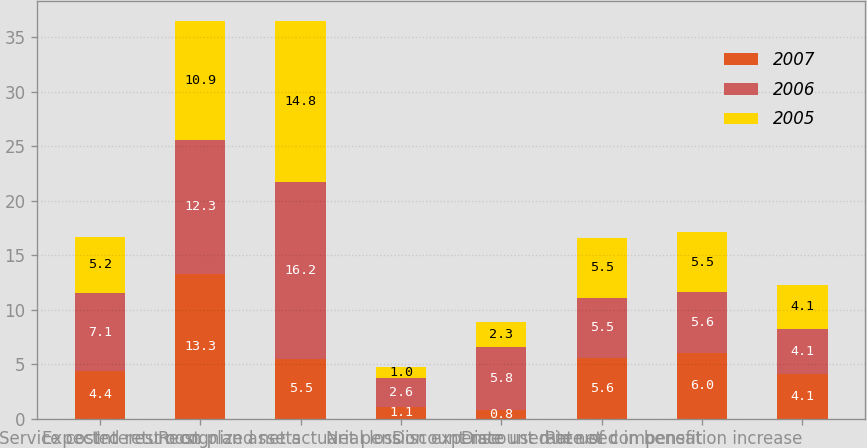Convert chart. <chart><loc_0><loc_0><loc_500><loc_500><stacked_bar_chart><ecel><fcel>Service cost<fcel>Interest cost<fcel>Expected return on plan assets<fcel>Recognized net actuarial loss<fcel>Net pension expense<fcel>Discount rate used in net<fcel>Discount rate used in benefit<fcel>Rate of compensation increase<nl><fcel>2007<fcel>4.4<fcel>13.3<fcel>5.5<fcel>1.1<fcel>0.8<fcel>5.6<fcel>6<fcel>4.1<nl><fcel>2006<fcel>7.1<fcel>12.3<fcel>16.2<fcel>2.6<fcel>5.8<fcel>5.5<fcel>5.6<fcel>4.1<nl><fcel>2005<fcel>5.2<fcel>10.9<fcel>14.8<fcel>1<fcel>2.3<fcel>5.5<fcel>5.5<fcel>4.1<nl></chart> 